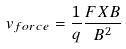<formula> <loc_0><loc_0><loc_500><loc_500>v _ { f o r c e } = \frac { 1 } { q } \frac { F X B } { B ^ { 2 } }</formula> 